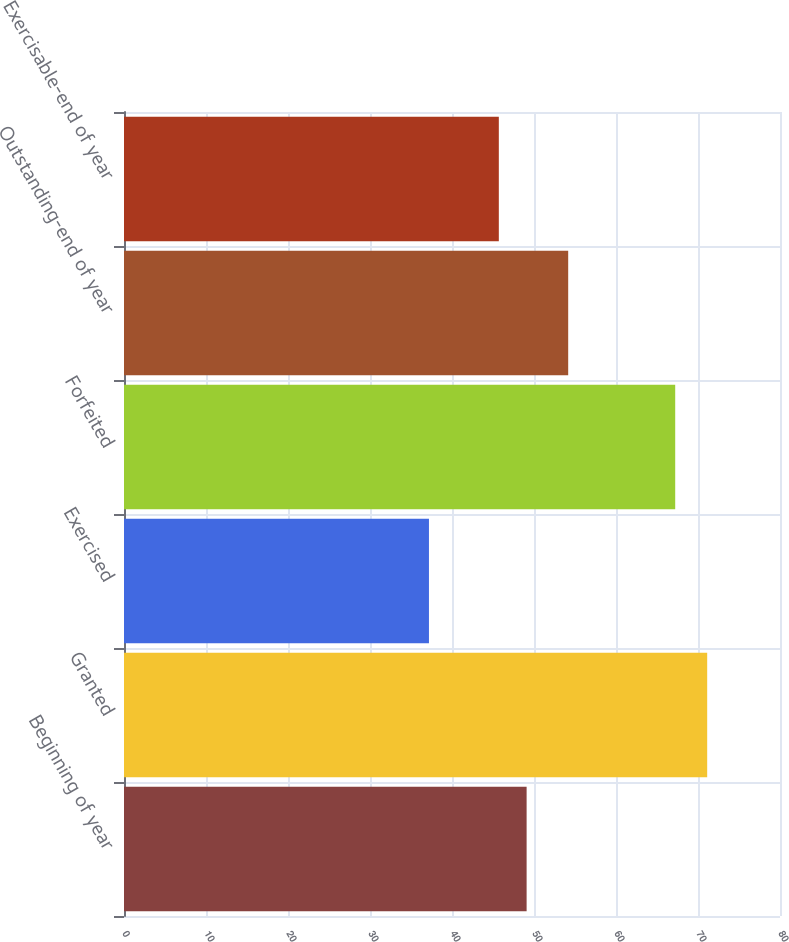<chart> <loc_0><loc_0><loc_500><loc_500><bar_chart><fcel>Beginning of year<fcel>Granted<fcel>Exercised<fcel>Forfeited<fcel>Outstanding-end of year<fcel>Exercisable-end of year<nl><fcel>49.1<fcel>71.12<fcel>37.19<fcel>67.22<fcel>54.17<fcel>45.71<nl></chart> 